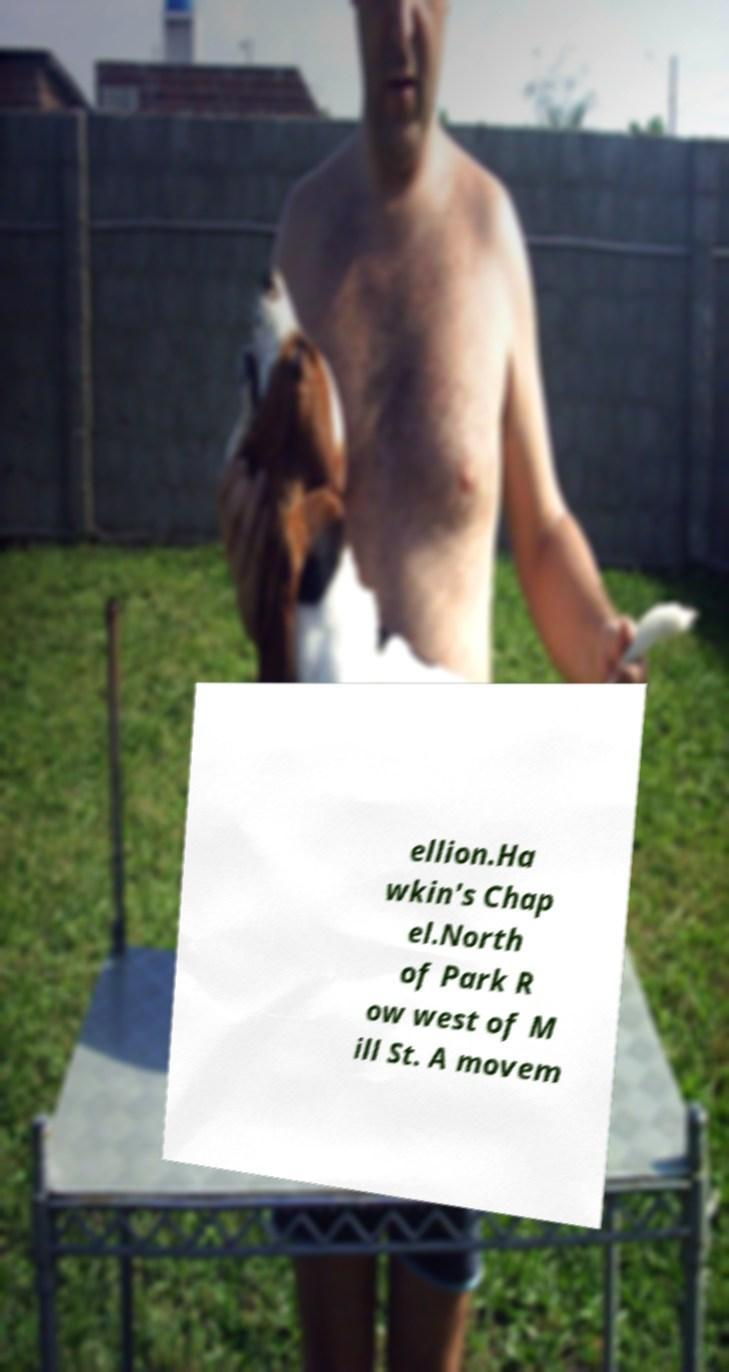Can you read and provide the text displayed in the image?This photo seems to have some interesting text. Can you extract and type it out for me? ellion.Ha wkin's Chap el.North of Park R ow west of M ill St. A movem 